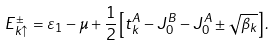<formula> <loc_0><loc_0><loc_500><loc_500>E _ { k \uparrow } ^ { \pm } = \varepsilon _ { 1 } - \mu + \frac { 1 } { 2 } \left [ { t _ { k } ^ { A } - J _ { 0 } ^ { B } - J _ { 0 } ^ { A } \pm \sqrt { \beta _ { k } } } \right ] .</formula> 